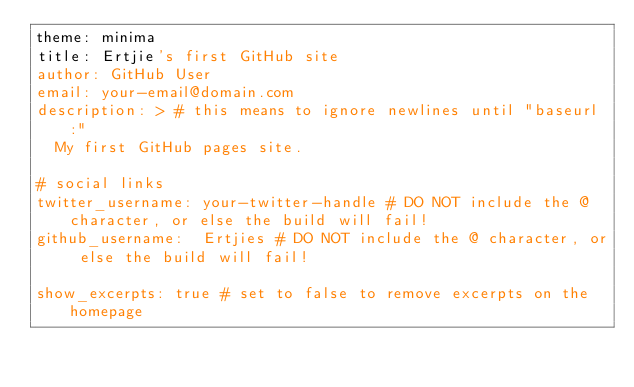<code> <loc_0><loc_0><loc_500><loc_500><_YAML_>theme: minima
title: Ertjie's first GitHub site
author: GitHub User
email: your-email@domain.com
description: > # this means to ignore newlines until "baseurl:"
  My first GitHub pages site.

# social links
twitter_username: your-twitter-handle # DO NOT include the @ character, or else the build will fail!
github_username:  Ertjies # DO NOT include the @ character, or else the build will fail!

show_excerpts: true # set to false to remove excerpts on the homepage
</code> 